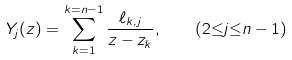<formula> <loc_0><loc_0><loc_500><loc_500>Y _ { j } ( z ) = \sum _ { k = 1 } ^ { k = n - 1 } \frac { \ell _ { k , j } } { z - z _ { k } } , \quad ( 2 { \leq } j { \leq } n - 1 )</formula> 